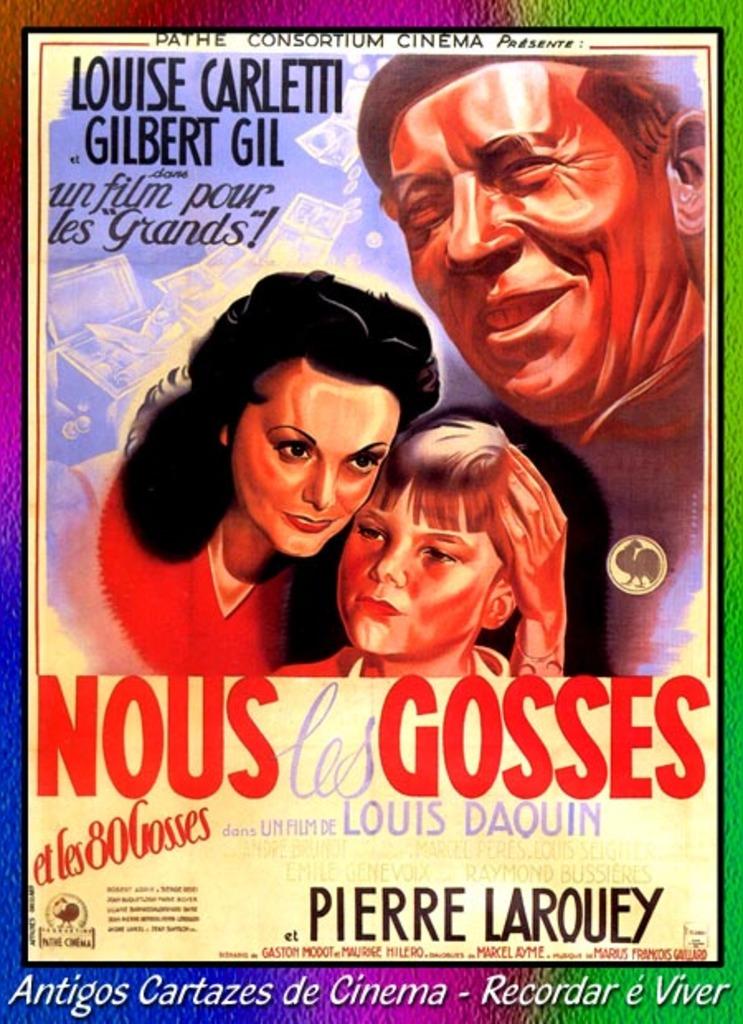What is the title of the movie?
Offer a very short reply. Nous gosses. Who is the main star in this movie?
Provide a succinct answer. Louise carletti. 